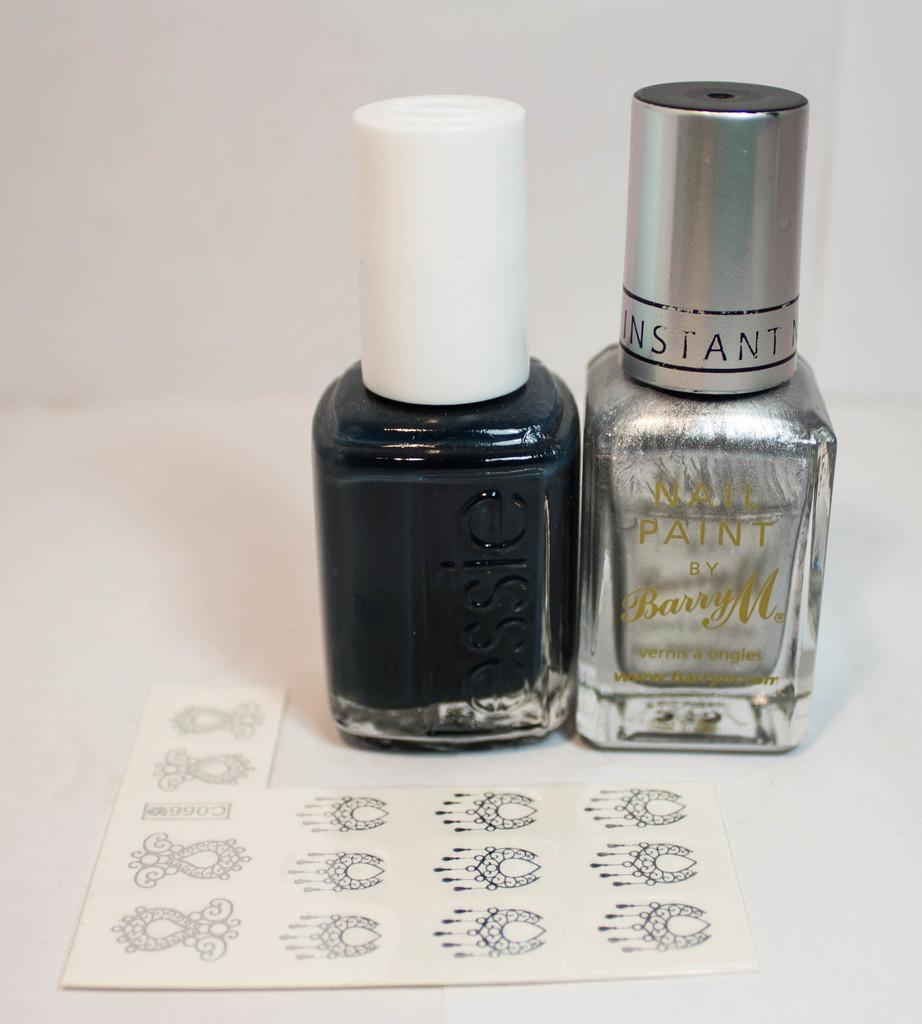<image>
Create a compact narrative representing the image presented. A sheet of nail art stickers next to a bottle of elsie Black nail polish and one bottle of clear polish by Barry M. 